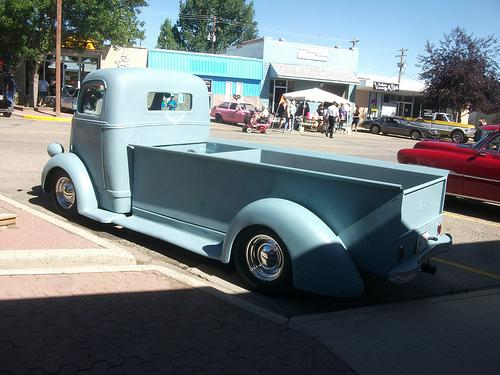Question: why is the truck here?
Choices:
A. Tow the car.
B. Car Show.
C. Put out the fire.
D. Deliver the mail.
Answer with the letter. Answer: B Question: how many vehicles are visible in the picture?
Choices:
A. 4.
B. 5.
C. 7.
D. 6.
Answer with the letter. Answer: B Question: what color are the hubcaps of the blue truck?
Choices:
A. Grey.
B. Silver.
C. White.
D. Black.
Answer with the letter. Answer: B 